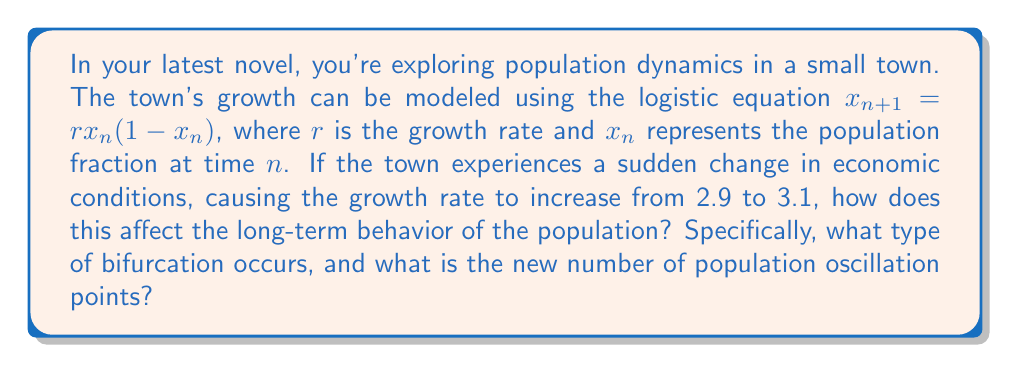Could you help me with this problem? To analyze this situation, we need to understand the behavior of the logistic map at different values of $r$:

1. For $1 < r < 3$, the population converges to a single fixed point.

2. At $r = 3$, the system undergoes its first bifurcation, known as a period-doubling bifurcation.

3. For $3 < r < 1+\sqrt{6} \approx 3.45$, the population oscillates between two values.

4. As $r$ increases further, more period-doubling bifurcations occur, leading to cycles of 4, 8, 16, and so on.

In this case:

- Initial growth rate: $r_1 = 2.9$
  At this rate, the population converges to a single fixed point.

- New growth rate: $r_2 = 3.1$
  This rate is just above the first bifurcation point ($r = 3$).

The change from $r_1 = 2.9$ to $r_2 = 3.1$ causes the system to go through a period-doubling bifurcation. This means:

1. The stable fixed point becomes unstable.
2. Two new stable fixed points emerge.

Therefore, the long-term behavior changes from a single stable population level to an oscillation between two different population levels.

The type of bifurcation that occurs is a period-doubling bifurcation, and the new number of population oscillation points is 2.
Answer: Period-doubling bifurcation; 2 oscillation points 